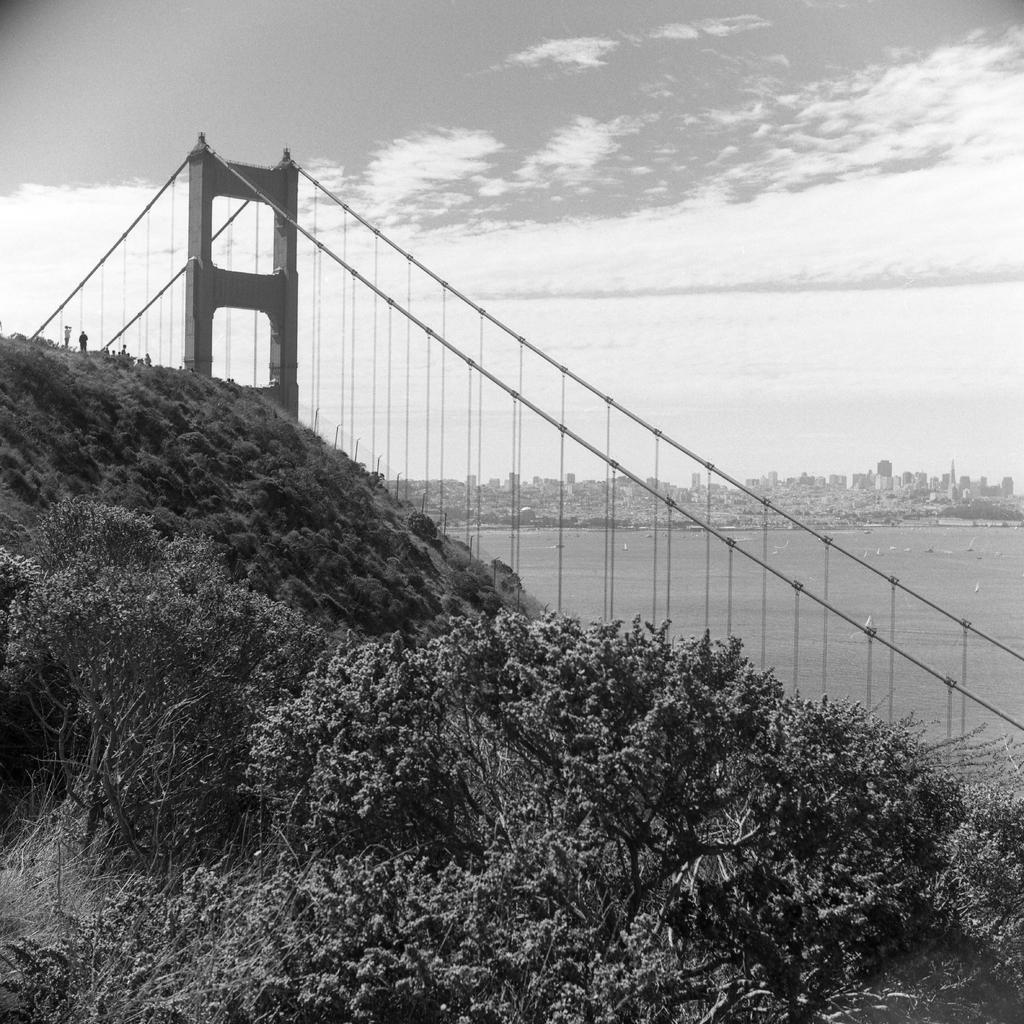What type of vegetation can be seen in the image? There are trees in the image. What type of structure is present in the image? There is a bridge in the image. What is on the right side of the image? There is water on the right side of the image. What is visible at the top of the image? The sky is visible at the top of the image. What type of bit is attached to the thread on the twig in the image? There is no bit, thread, or twig present in the image. 